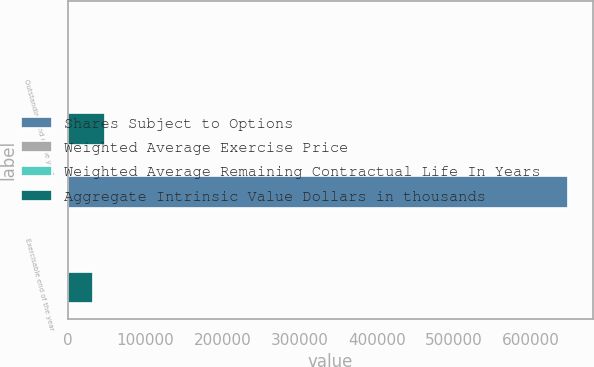Convert chart to OTSL. <chart><loc_0><loc_0><loc_500><loc_500><stacked_bar_chart><ecel><fcel>Outstanding end of the year<fcel>Exercisable end of the year<nl><fcel>Shares Subject to Options<fcel>75.93<fcel>647425<nl><fcel>Weighted Average Exercise Price<fcel>75.93<fcel>64.82<nl><fcel>Weighted Average Remaining Contractual Life In Years<fcel>7.3<fcel>6.1<nl><fcel>Aggregate Intrinsic Value Dollars in thousands<fcel>47974<fcel>32373<nl></chart> 